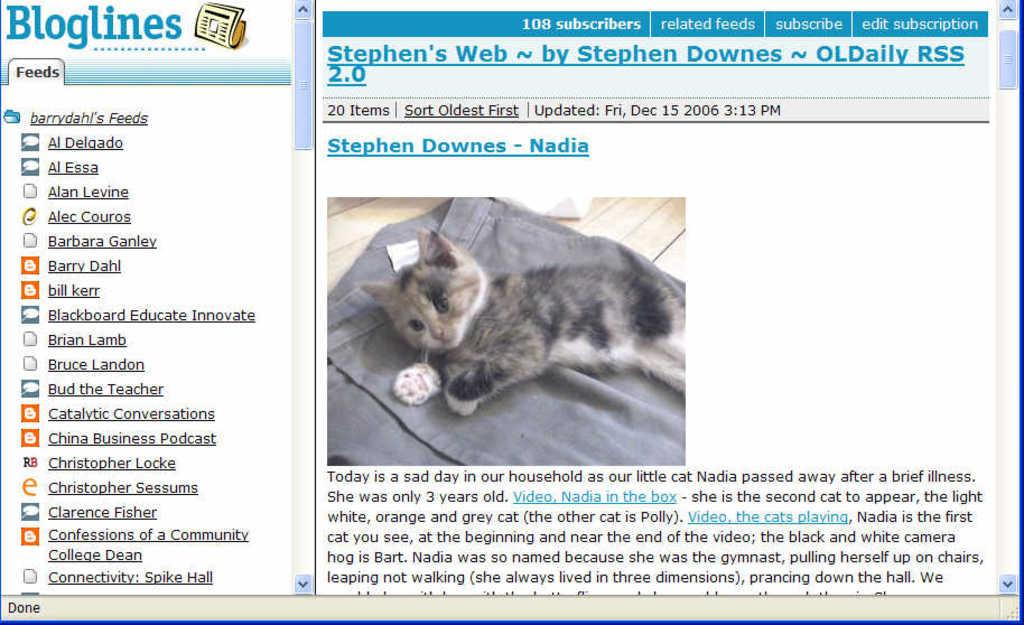What is the main subject of the image? The main subject of the image is a picture of a blog. What can be seen on the picture of the blog? The picture of the blog has some text on it. What other element is present in the image? There is a cat in the image. Can you describe the cat's location in the image? The cat is on a cloth in the image. What type of fowl can be seen interacting with the cat on the cloth in the image? There is no fowl present in the image, and the cat is not interacting with any other animals. 